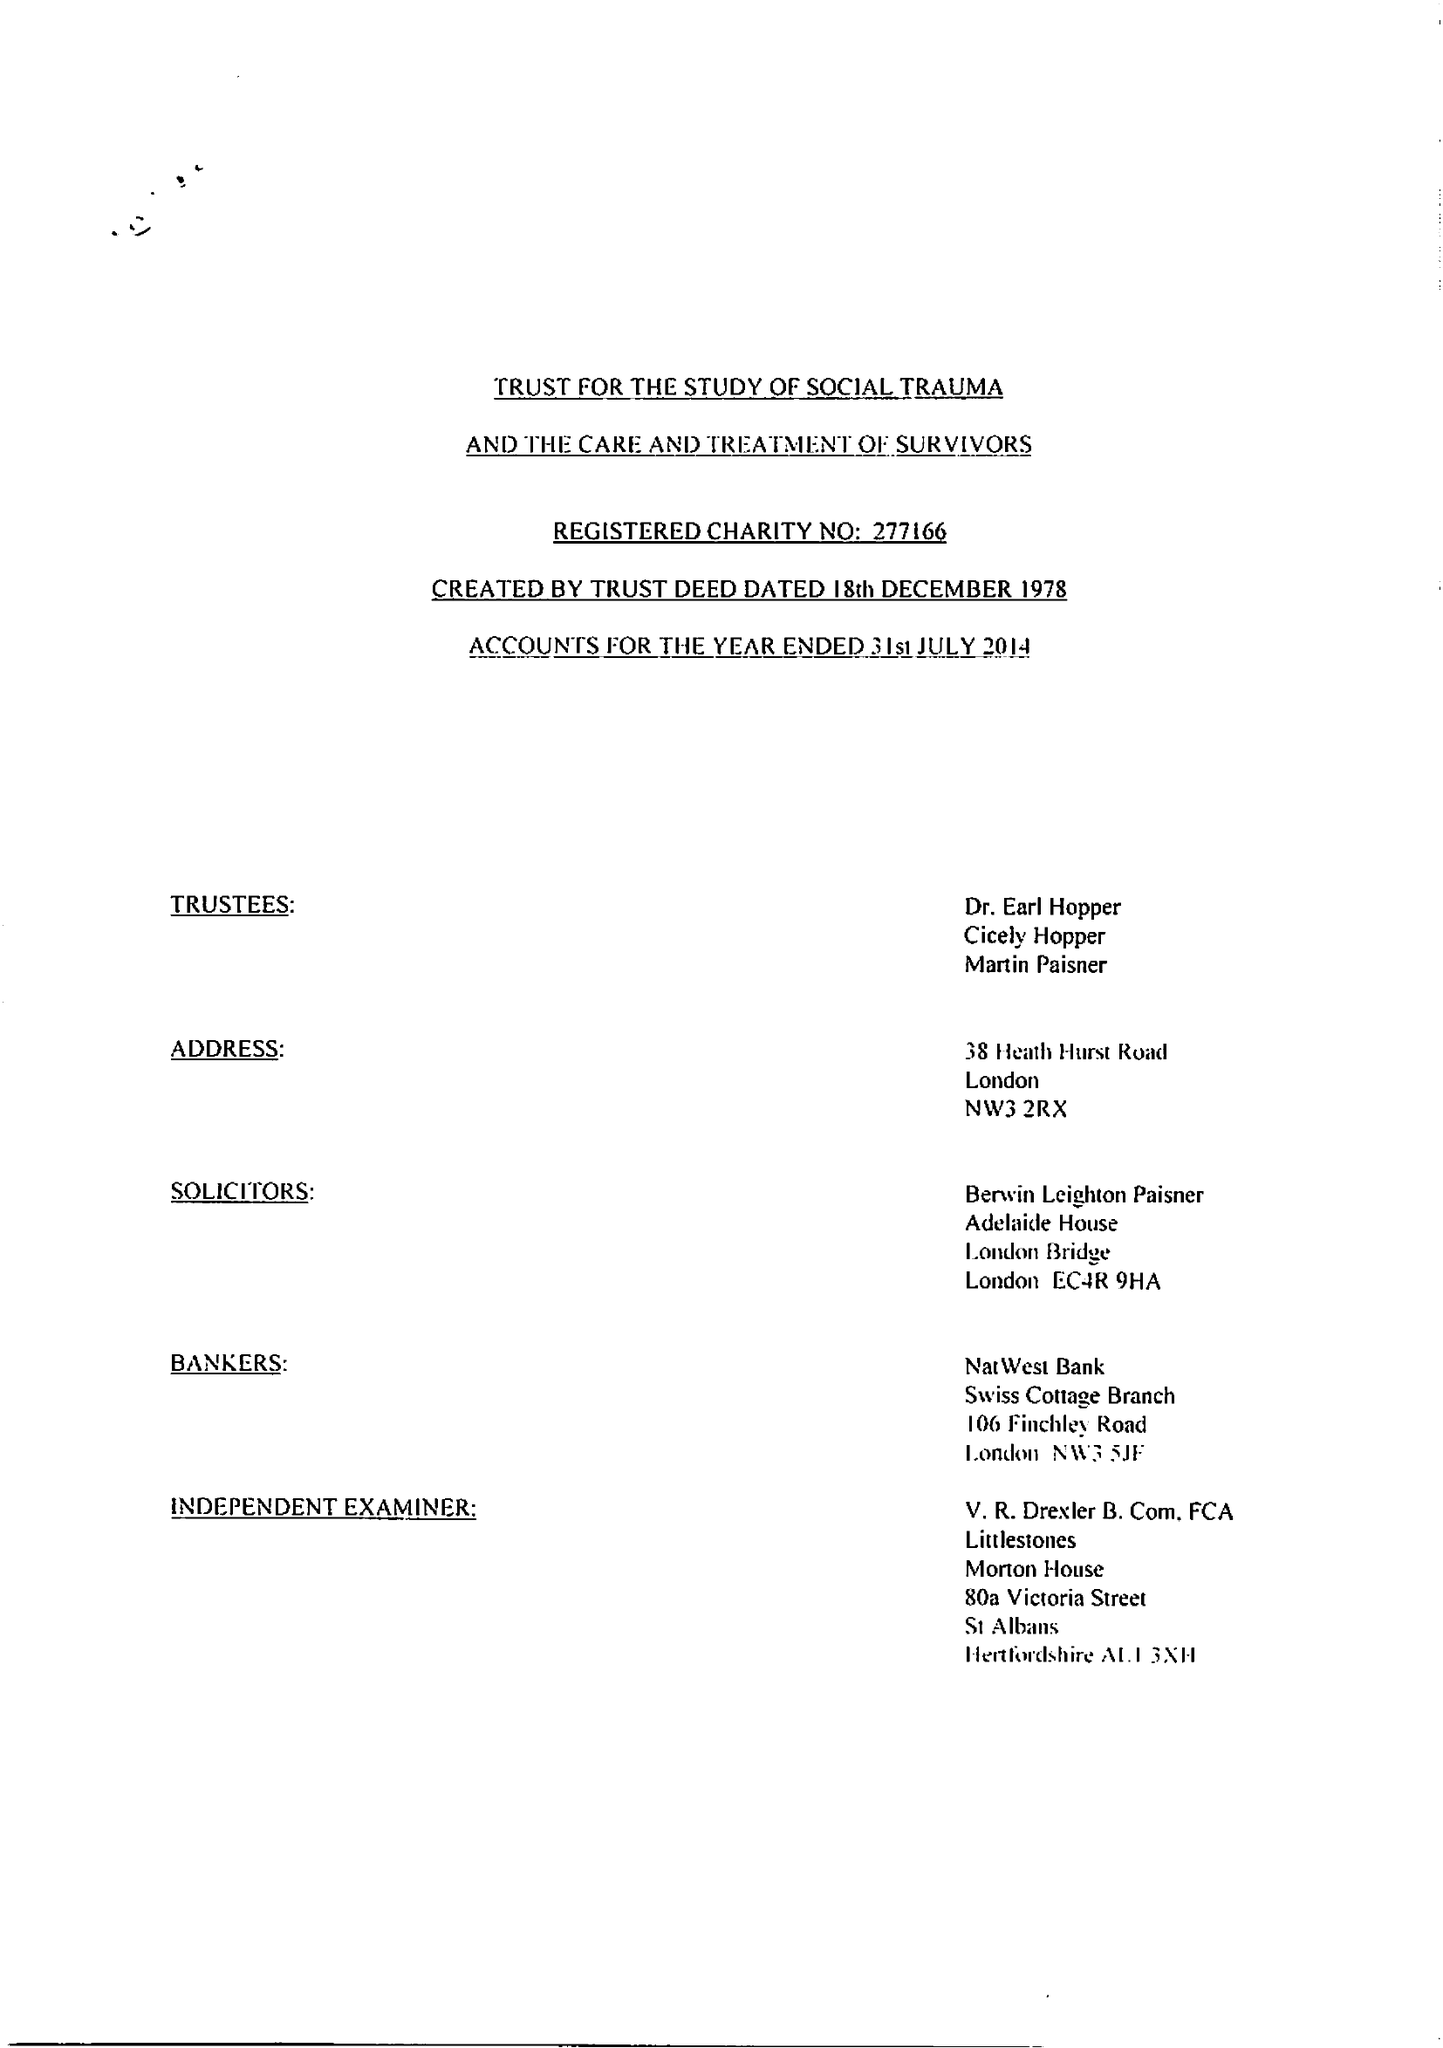What is the value for the address__post_town?
Answer the question using a single word or phrase. LONDON 